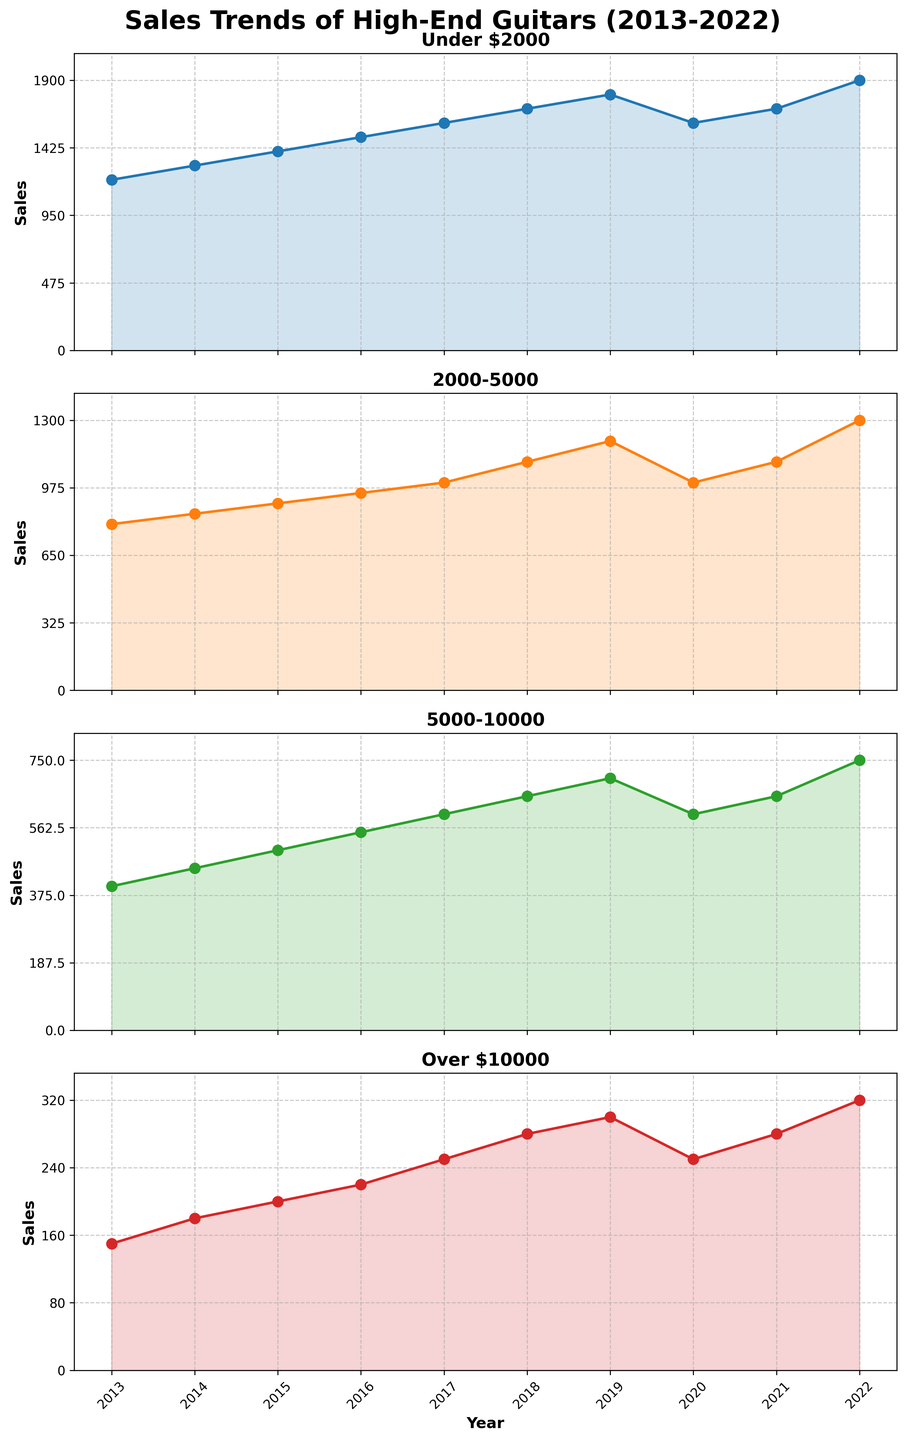How many sales were made in the "Under $2000" category in 2015? Look at the "Under $2000" subplot and find the data point for the year 2015. The sales were 1400.
Answer: 1400 Which category shows the highest sales in the year 2022? Look at the data points for each subplot in the year 2022. The "Under $2000" category has the highest sales with 1900.
Answer: Under $2000 What is the general trend of the 2016-2020 sales in the "Over $10000" category? Observe the "Over $10000" subplot specifically between 2016 and 2020. Sales displayed a growth trend from 220 in 2016 to 300 in 2019 but dropped to 250 in 2020.
Answer: Growth, then decline Compare the sales difference between 2014 and 2019 for the "2000-5000" category. Check the "2000-5000" subplot for sales in 2014 (850) and 2019 (1200). Calculate the difference: 1200 - 850 = 350.
Answer: 350 What was the average sales in the "5000-10000" category from 2013 to 2017? Gather the sales data for the "5000-10000" category from 2013 to 2017: (400, 450, 500, 550, 600). Add the values: 400 + 450 + 500 + 550 + 600 = 2500. Divide by 5: 2500 / 5 = 500.
Answer: 500 Which years saw the highest sales in each category? Identify the peak sales year in each subplot:
- Under $2000: 2022 (1900)
- 2000-5000: 2022 (1300)
- 5000-10000: 2022 (750)
- Over $10000: 2022 (320)
Answer: 2022 for all categories How did sales in the "Under $2000" category change from 2019 to 2020? In the "Under $2000" subplot, note the sales in 2019 (1800) and 2020 (1600). The sales decreased by 200: 1600 - 1800 = -200.
Answer: Decreased by 200 What pattern do you observe in sales for all categories in 2020-2021? Examine the subplots for sales in 2020-2021. All categories show a decline in 2020 followed by a rebound in 2021.
Answer: Decline then rebound 